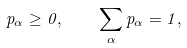Convert formula to latex. <formula><loc_0><loc_0><loc_500><loc_500>p _ { \alpha } \geq 0 , \quad \sum _ { \alpha } p _ { \alpha } = 1 ,</formula> 